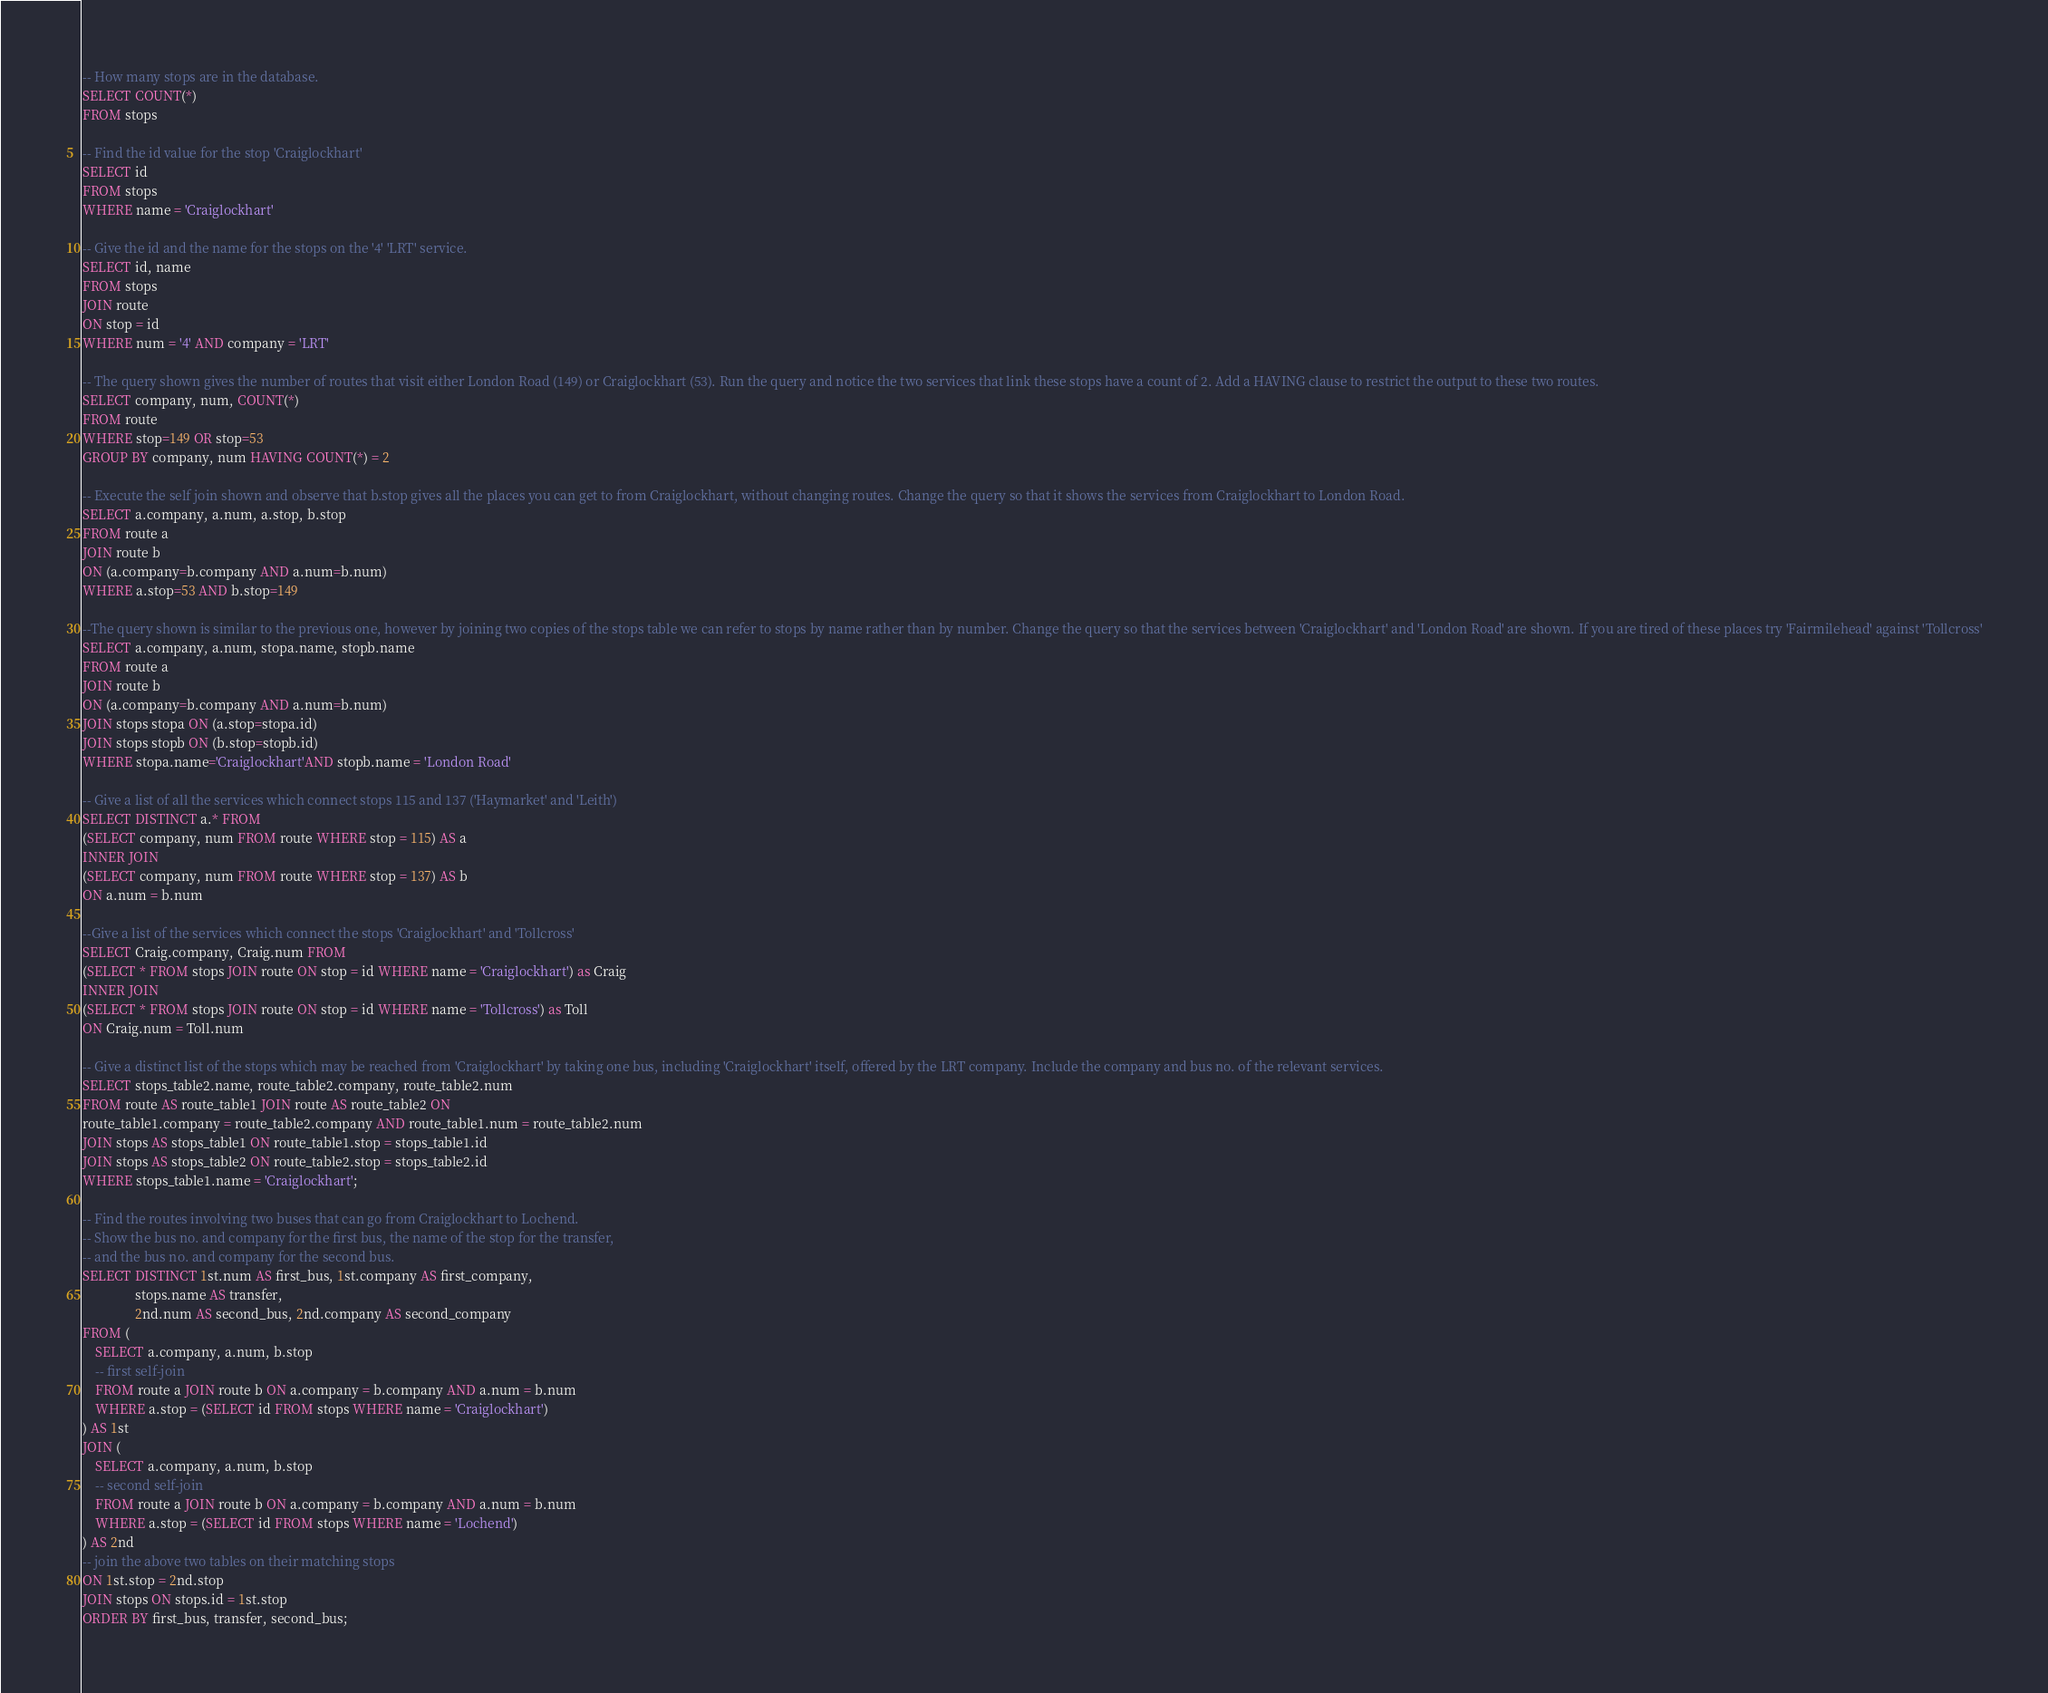Convert code to text. <code><loc_0><loc_0><loc_500><loc_500><_SQL_>-- How many stops are in the database.
SELECT COUNT(*) 
FROM stops

-- Find the id value for the stop 'Craiglockhart'
SELECT id 
FROM stops 
WHERE name = 'Craiglockhart'

-- Give the id and the name for the stops on the '4' 'LRT' service.
SELECT id, name 
FROM stops 
JOIN route 
ON stop = id 
WHERE num = '4' AND company = 'LRT'

-- The query shown gives the number of routes that visit either London Road (149) or Craiglockhart (53). Run the query and notice the two services that link these stops have a count of 2. Add a HAVING clause to restrict the output to these two routes.
SELECT company, num, COUNT(*)
FROM route 
WHERE stop=149 OR stop=53
GROUP BY company, num HAVING COUNT(*) = 2

-- Execute the self join shown and observe that b.stop gives all the places you can get to from Craiglockhart, without changing routes. Change the query so that it shows the services from Craiglockhart to London Road.
SELECT a.company, a.num, a.stop, b.stop
FROM route a 
JOIN route b 
ON (a.company=b.company AND a.num=b.num)
WHERE a.stop=53 AND b.stop=149

--The query shown is similar to the previous one, however by joining two copies of the stops table we can refer to stops by name rather than by number. Change the query so that the services between 'Craiglockhart' and 'London Road' are shown. If you are tired of these places try 'Fairmilehead' against 'Tollcross'
SELECT a.company, a.num, stopa.name, stopb.name
FROM route a 
JOIN route b 
ON (a.company=b.company AND a.num=b.num)
JOIN stops stopa ON (a.stop=stopa.id)
JOIN stops stopb ON (b.stop=stopb.id)
WHERE stopa.name='Craiglockhart'AND stopb.name = 'London Road'

-- Give a list of all the services which connect stops 115 and 137 ('Haymarket' and 'Leith')
SELECT DISTINCT a.* FROM 
(SELECT company, num FROM route WHERE stop = 115) AS a
INNER JOIN
(SELECT company, num FROM route WHERE stop = 137) AS b
ON a.num = b.num

--Give a list of the services which connect the stops 'Craiglockhart' and 'Tollcross'
SELECT Craig.company, Craig.num FROM
(SELECT * FROM stops JOIN route ON stop = id WHERE name = 'Craiglockhart') as Craig
INNER JOIN
(SELECT * FROM stops JOIN route ON stop = id WHERE name = 'Tollcross') as Toll
ON Craig.num = Toll.num

-- Give a distinct list of the stops which may be reached from 'Craiglockhart' by taking one bus, including 'Craiglockhart' itself, offered by the LRT company. Include the company and bus no. of the relevant services.
SELECT stops_table2.name, route_table2.company, route_table2.num
FROM route AS route_table1 JOIN route AS route_table2 ON
route_table1.company = route_table2.company AND route_table1.num = route_table2.num
JOIN stops AS stops_table1 ON route_table1.stop = stops_table1.id
JOIN stops AS stops_table2 ON route_table2.stop = stops_table2.id
WHERE stops_table1.name = 'Craiglockhart';

-- Find the routes involving two buses that can go from Craiglockhart to Lochend.
-- Show the bus no. and company for the first bus, the name of the stop for the transfer,
-- and the bus no. and company for the second bus.
SELECT DISTINCT 1st.num AS first_bus, 1st.company AS first_company, 
                stops.name AS transfer, 
                2nd.num AS second_bus, 2nd.company AS second_company
FROM (
    SELECT a.company, a.num, b.stop
    -- first self-join
    FROM route a JOIN route b ON a.company = b.company AND a.num = b.num
    WHERE a.stop = (SELECT id FROM stops WHERE name = 'Craiglockhart')
) AS 1st
JOIN (
    SELECT a.company, a.num, b.stop
    -- second self-join
    FROM route a JOIN route b ON a.company = b.company AND a.num = b.num
    WHERE a.stop = (SELECT id FROM stops WHERE name = 'Lochend')
) AS 2nd
-- join the above two tables on their matching stops
ON 1st.stop = 2nd.stop
JOIN stops ON stops.id = 1st.stop
ORDER BY first_bus, transfer, second_bus;

</code> 